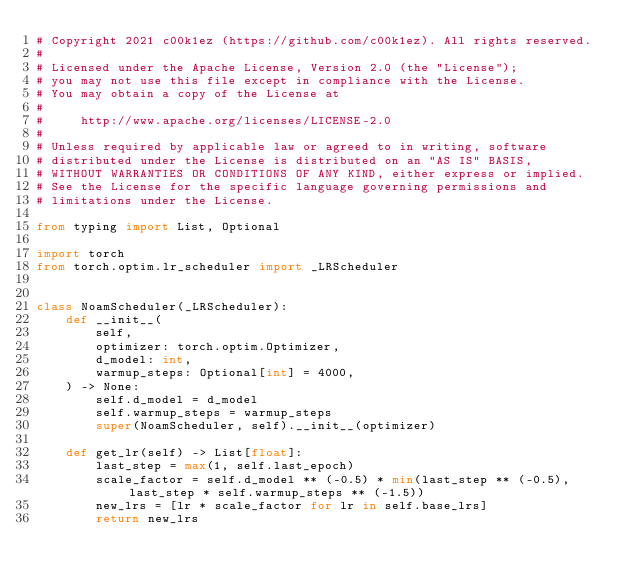<code> <loc_0><loc_0><loc_500><loc_500><_Python_># Copyright 2021 c00k1ez (https://github.com/c00k1ez). All rights reserved.
#
# Licensed under the Apache License, Version 2.0 (the "License");
# you may not use this file except in compliance with the License.
# You may obtain a copy of the License at
#
#     http://www.apache.org/licenses/LICENSE-2.0
#
# Unless required by applicable law or agreed to in writing, software
# distributed under the License is distributed on an "AS IS" BASIS,
# WITHOUT WARRANTIES OR CONDITIONS OF ANY KIND, either express or implied.
# See the License for the specific language governing permissions and
# limitations under the License.

from typing import List, Optional

import torch
from torch.optim.lr_scheduler import _LRScheduler


class NoamScheduler(_LRScheduler):
    def __init__(
        self,
        optimizer: torch.optim.Optimizer,
        d_model: int,
        warmup_steps: Optional[int] = 4000,
    ) -> None:
        self.d_model = d_model
        self.warmup_steps = warmup_steps
        super(NoamScheduler, self).__init__(optimizer)

    def get_lr(self) -> List[float]:
        last_step = max(1, self.last_epoch)
        scale_factor = self.d_model ** (-0.5) * min(last_step ** (-0.5), last_step * self.warmup_steps ** (-1.5))
        new_lrs = [lr * scale_factor for lr in self.base_lrs]
        return new_lrs
</code> 